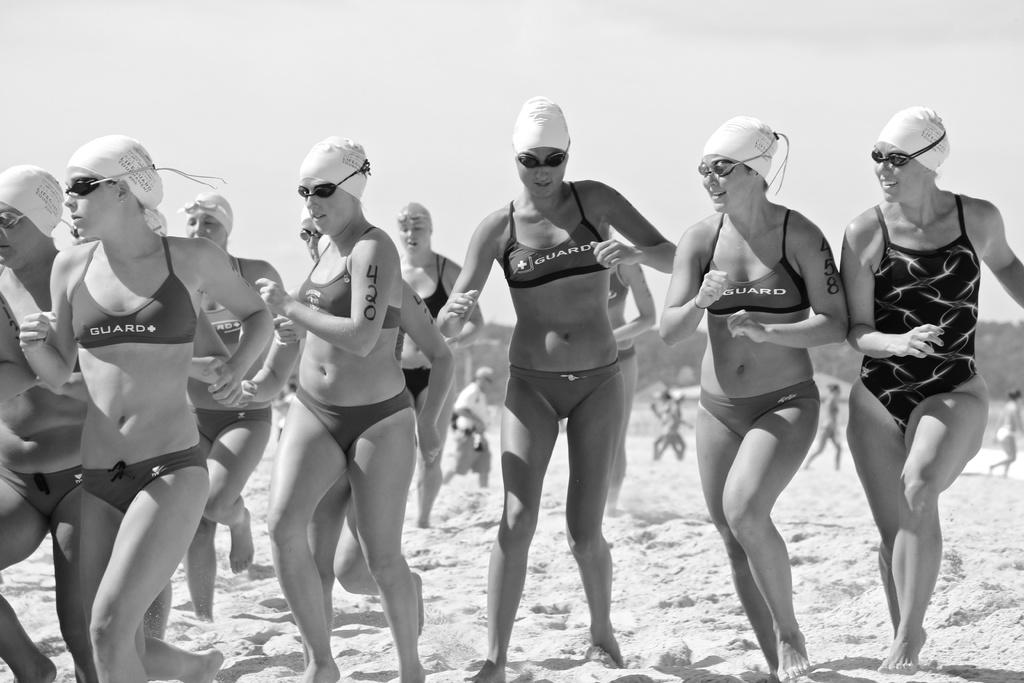What is the color scheme of the image? The image is black and white. What can be seen in the image? There are girls in the image. What are the girls doing in the image? The girls are running in the sand. What are the girls wearing in the image? The girls are wearing bikinis, spectacles, and caps. What is the profit margin of the industry depicted in the image? There is no industry depicted in the image, as it features girls running in the sand. What is the taste of the sand in the image? The image does not convey the taste of the sand; it only shows the girls running in it. 